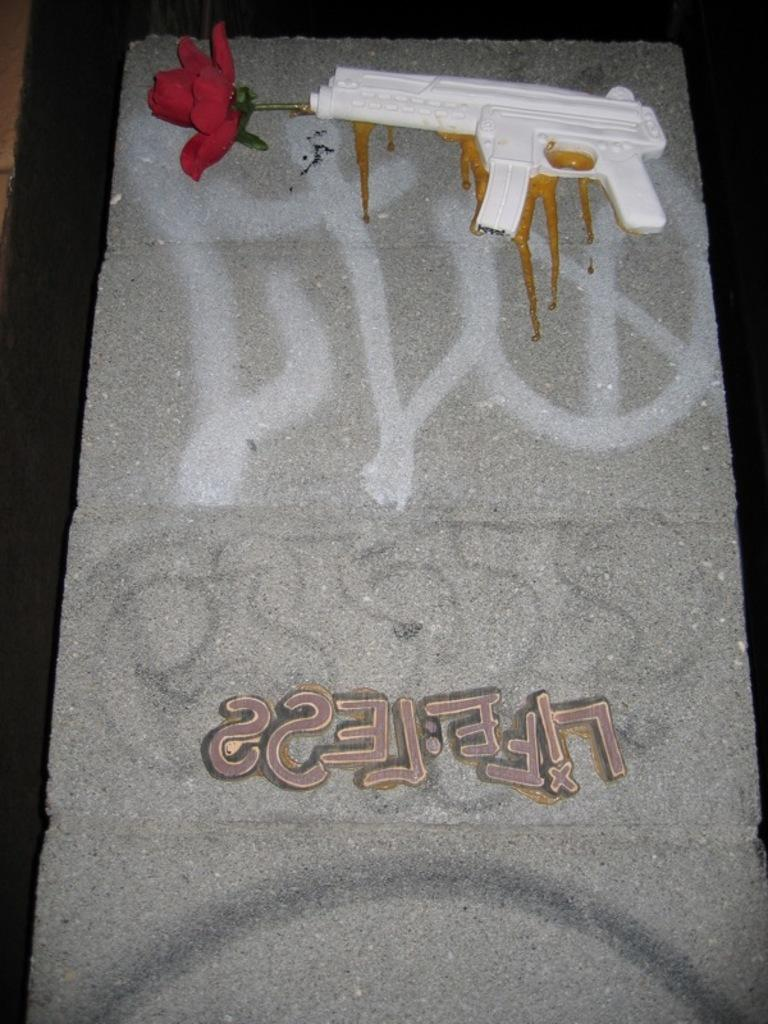What type of toy is present in the image? There is a toy gun in the image. What other object can be seen in the image? There is a flower in the image. What is the unusual object in the image? There are letters written on a stone in the image. How would you describe the overall lighting in the image? The background of the image appears dark. Who is the maid in the image? There is no maid present in the image. What type of hose is used to water the flower in the image? There is no hose visible in the image, and the flower does not appear to be watered. 